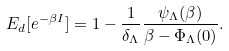Convert formula to latex. <formula><loc_0><loc_0><loc_500><loc_500>E _ { d } [ e ^ { - \beta I } ] = 1 - \frac { 1 } { \delta _ { \Lambda } } \frac { \psi _ { \Lambda } ( \beta ) } { \beta - \Phi _ { \Lambda } ( 0 ) } .</formula> 